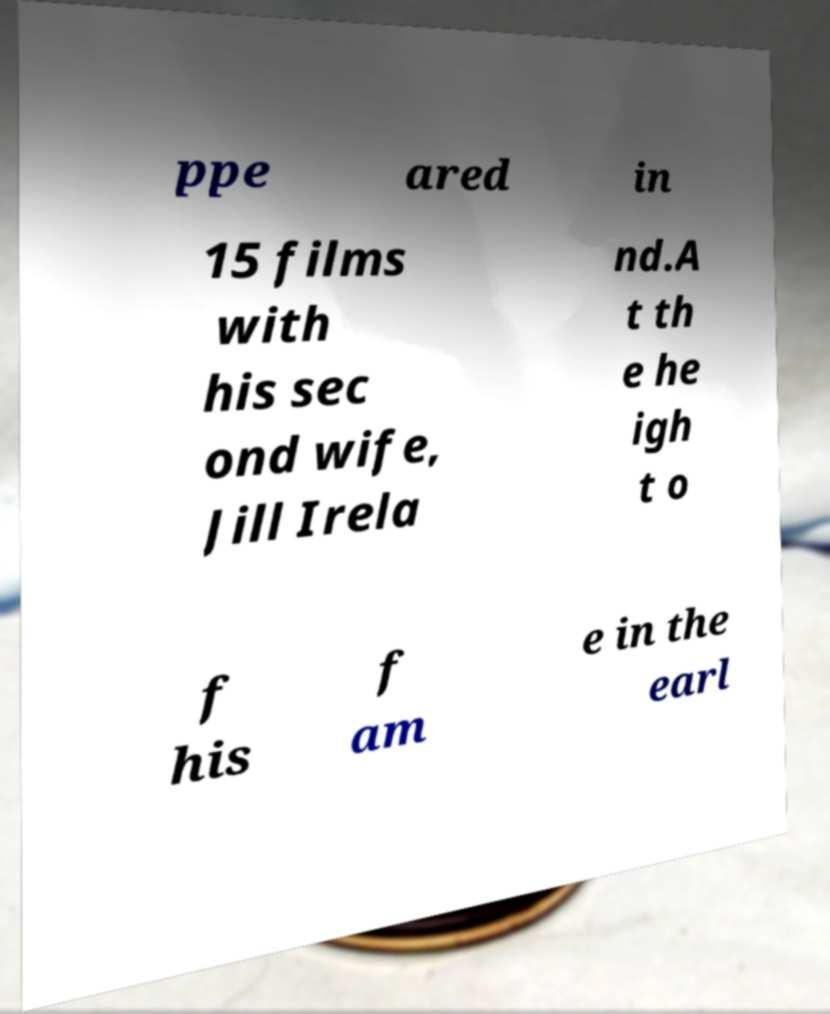Could you extract and type out the text from this image? ppe ared in 15 films with his sec ond wife, Jill Irela nd.A t th e he igh t o f his f am e in the earl 